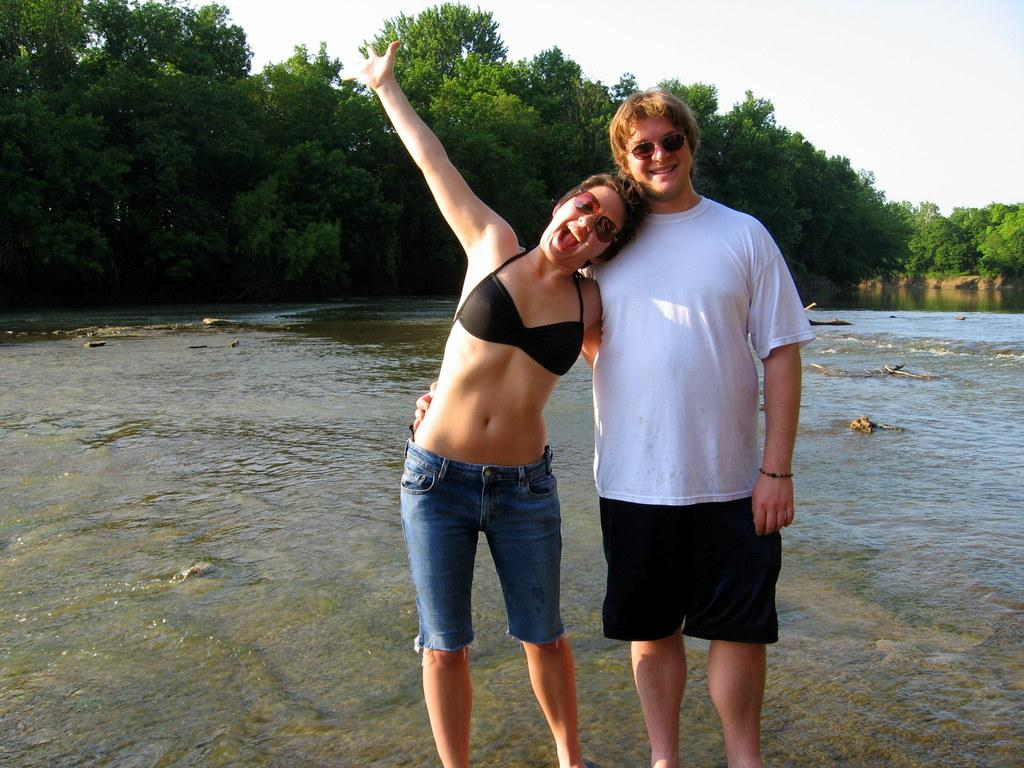How many people are present in the image? There are two people, a man and a woman, standing in the image. What is visible in the background of the image? There is water, green color trees, and the sky visible in the image. What is the condition of the sky in the image? The sky is cloudy in the image. What type of hot offer can be seen on the seashore in the image? There is no seashore or hot offer present in the image. The image features a man and a woman standing near water, trees, and a cloudy sky. 